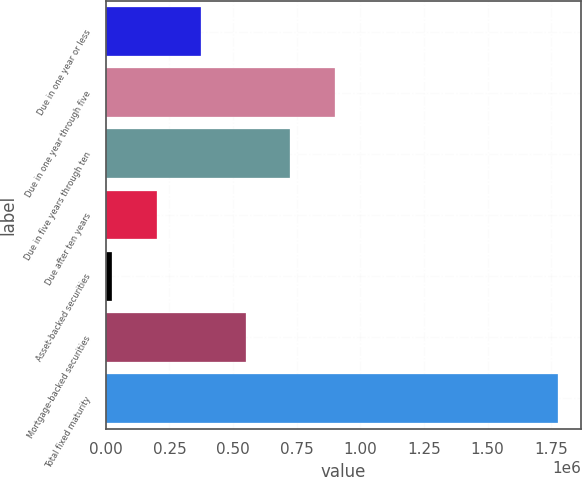Convert chart to OTSL. <chart><loc_0><loc_0><loc_500><loc_500><bar_chart><fcel>Due in one year or less<fcel>Due in one year through five<fcel>Due in five years through ten<fcel>Due after ten years<fcel>Asset-backed securities<fcel>Mortgage-backed securities<fcel>Total fixed maturity<nl><fcel>374995<fcel>900746<fcel>725495<fcel>199744<fcel>24494<fcel>550245<fcel>1.777e+06<nl></chart> 